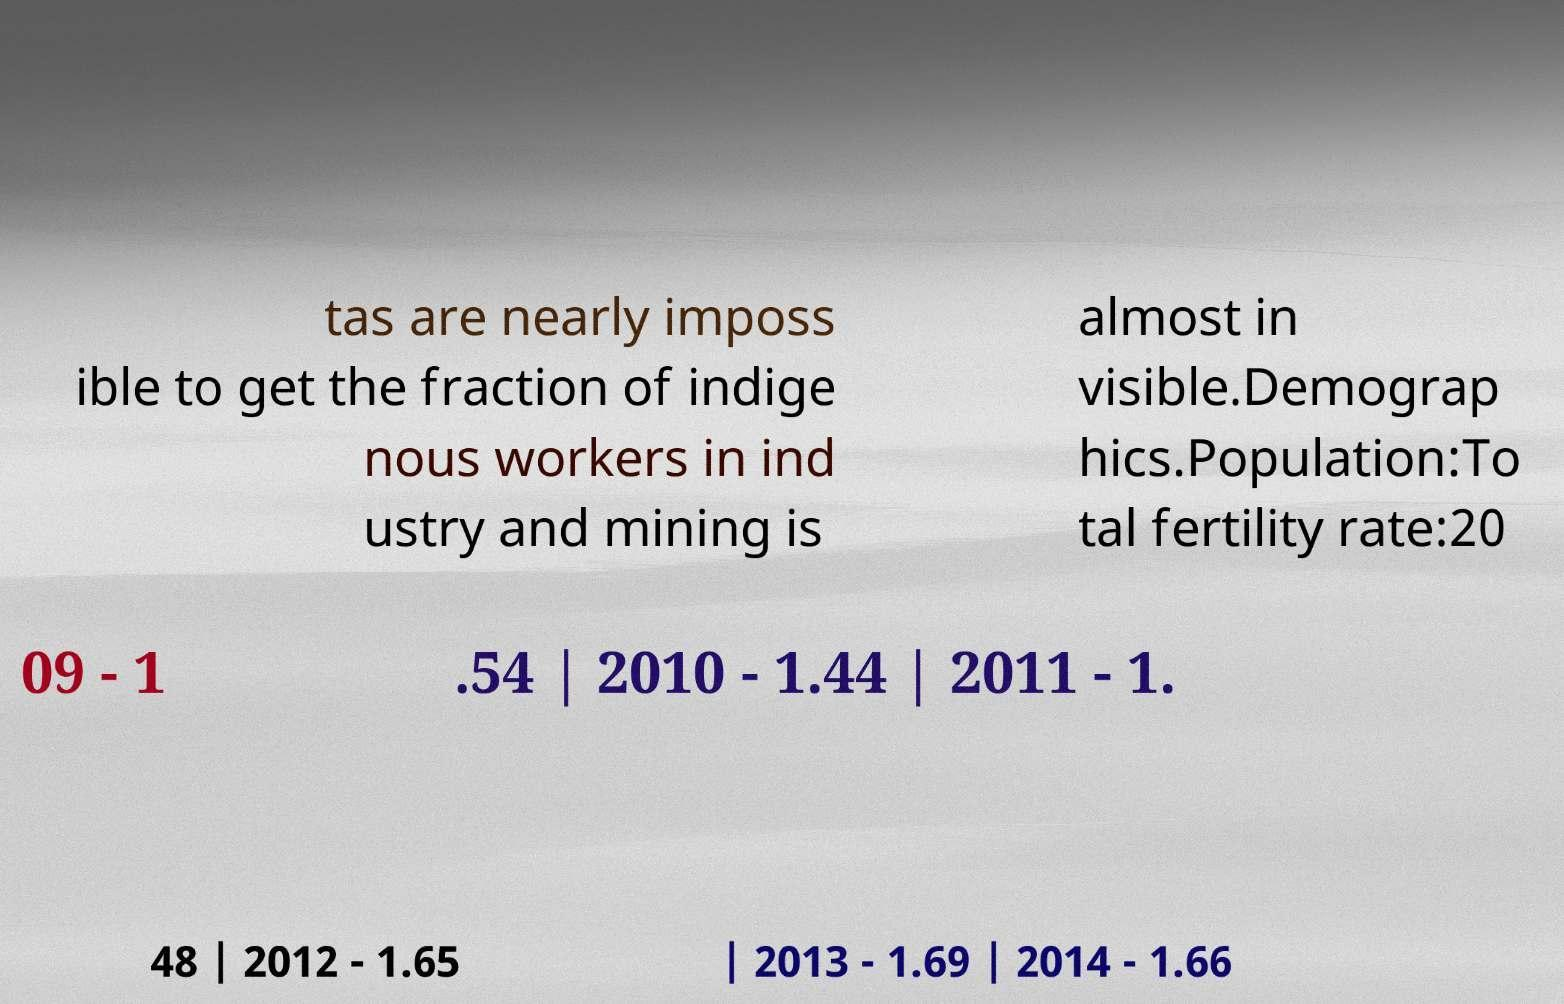Please identify and transcribe the text found in this image. tas are nearly imposs ible to get the fraction of indige nous workers in ind ustry and mining is almost in visible.Demograp hics.Population:To tal fertility rate:20 09 - 1 .54 | 2010 - 1.44 | 2011 - 1. 48 | 2012 - 1.65 | 2013 - 1.69 | 2014 - 1.66 